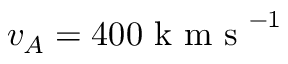Convert formula to latex. <formula><loc_0><loc_0><loc_500><loc_500>v _ { A } = 4 0 0 k m s ^ { - 1 }</formula> 